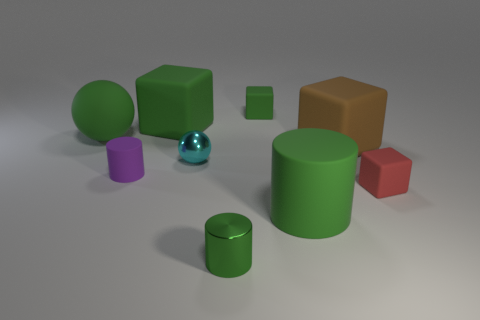There is another cylinder that is the same color as the tiny shiny cylinder; what is its material?
Ensure brevity in your answer.  Rubber. Does the small sphere have the same color as the cylinder that is to the left of the big green block?
Your answer should be compact. No. Are there more small green things than metallic cylinders?
Give a very brief answer. Yes. The green rubber object that is the same shape as the small cyan object is what size?
Provide a succinct answer. Large. Are the cyan ball and the tiny cylinder that is behind the small red object made of the same material?
Offer a very short reply. No. What number of things are purple rubber things or small gray metallic cylinders?
Give a very brief answer. 1. There is a rubber cylinder behind the tiny red thing; is it the same size as the matte thing that is in front of the small red matte cube?
Your response must be concise. No. How many blocks are either small cyan things or large brown rubber things?
Your response must be concise. 1. Is there a tiny green metallic object?
Your answer should be very brief. Yes. Is there any other thing that is the same shape as the tiny red matte thing?
Give a very brief answer. Yes. 